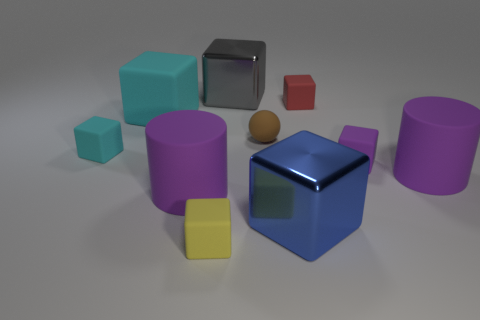Subtract all yellow cylinders. How many yellow blocks are left? 1 Subtract all blue blocks. How many blocks are left? 6 Subtract all tiny yellow blocks. How many blocks are left? 6 Subtract all brown rubber things. Subtract all matte cubes. How many objects are left? 4 Add 2 small cyan rubber objects. How many small cyan rubber objects are left? 3 Add 4 big cyan cubes. How many big cyan cubes exist? 5 Subtract 0 red cylinders. How many objects are left? 10 Subtract all cubes. How many objects are left? 3 Subtract 7 cubes. How many cubes are left? 0 Subtract all cyan cubes. Subtract all purple spheres. How many cubes are left? 5 